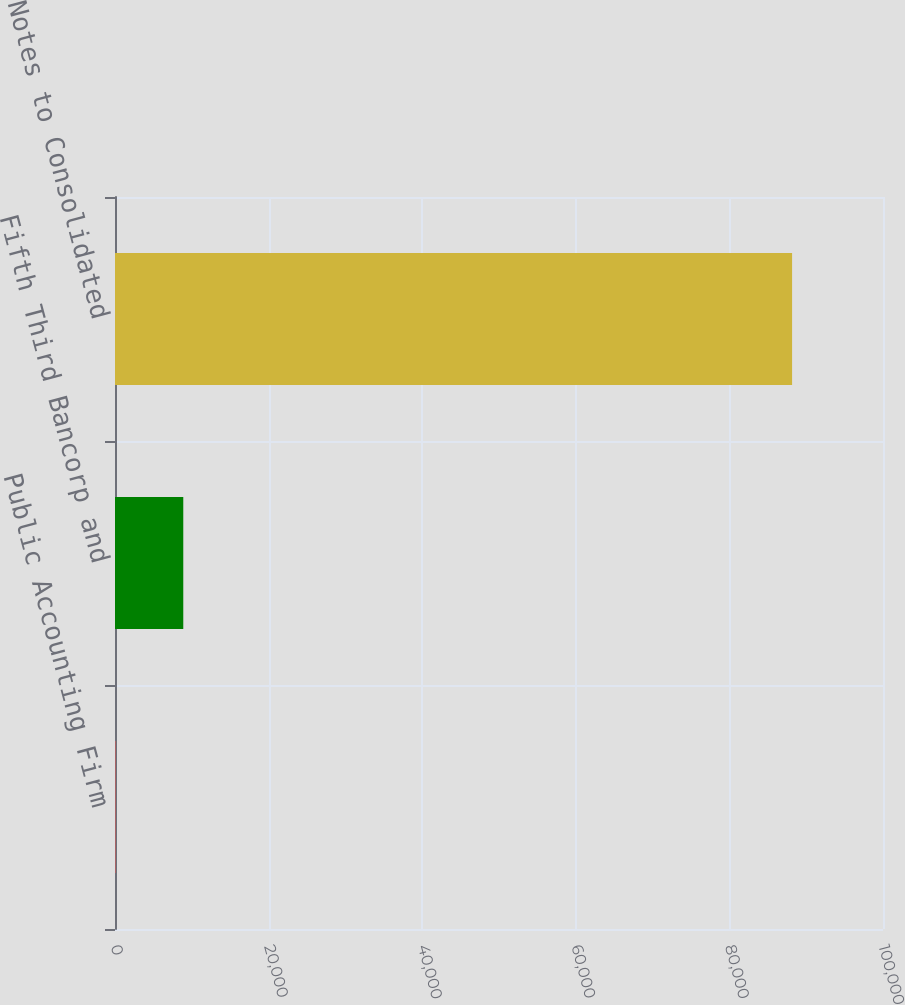Convert chart to OTSL. <chart><loc_0><loc_0><loc_500><loc_500><bar_chart><fcel>Public Accounting Firm<fcel>Fifth Third Bancorp and<fcel>Notes to Consolidated<nl><fcel>82<fcel>8890<fcel>88162<nl></chart> 